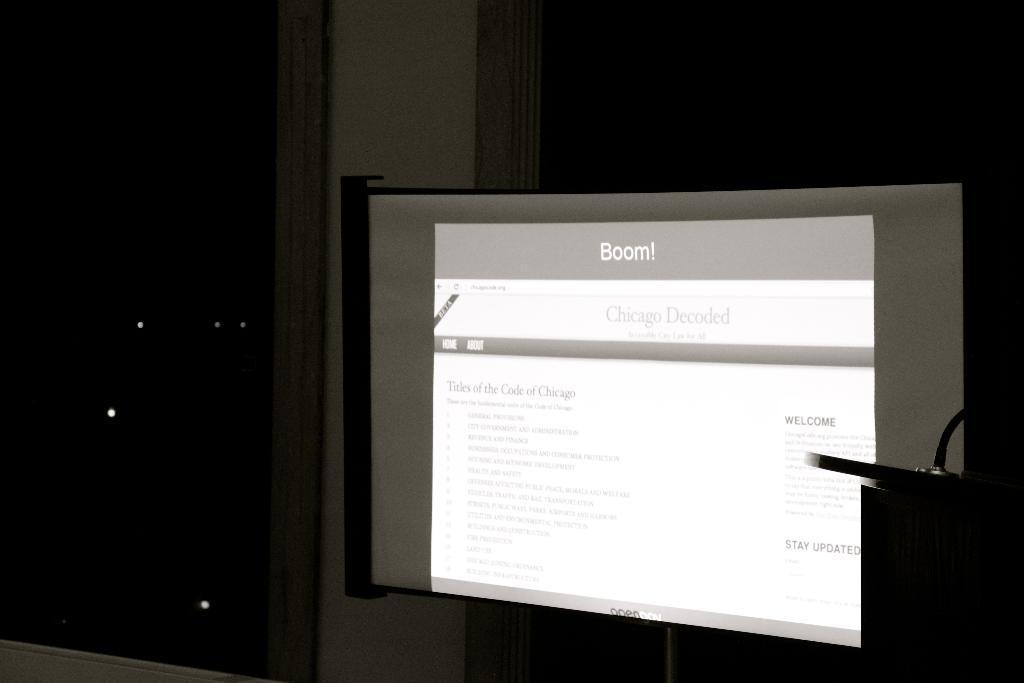Can you describe this image briefly? In this picture we can see screen on the board. 